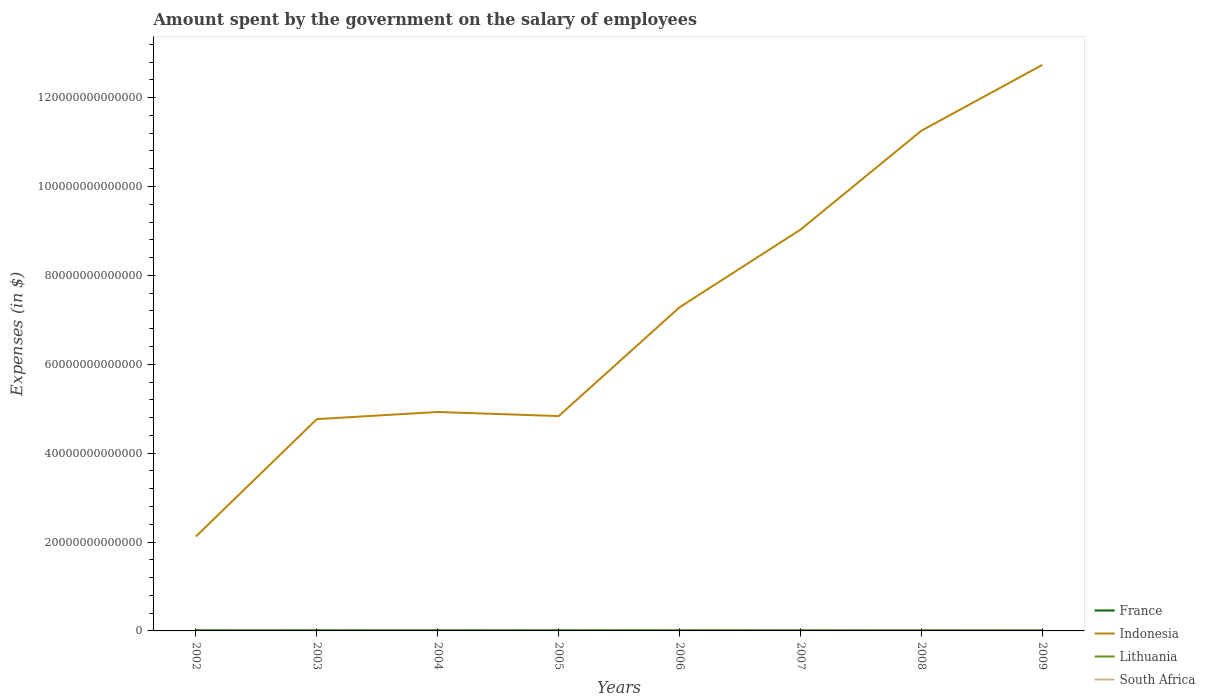How many different coloured lines are there?
Keep it short and to the point. 4. Does the line corresponding to Lithuania intersect with the line corresponding to South Africa?
Your response must be concise. No. Across all years, what is the maximum amount spent on the salary of employees by the government in Lithuania?
Provide a short and direct response. 2.72e+09. In which year was the amount spent on the salary of employees by the government in Indonesia maximum?
Offer a very short reply. 2002. What is the total amount spent on the salary of employees by the government in Lithuania in the graph?
Provide a short and direct response. -7.26e+08. What is the difference between the highest and the second highest amount spent on the salary of employees by the government in South Africa?
Provide a succinct answer. 6.03e+1. What is the difference between the highest and the lowest amount spent on the salary of employees by the government in South Africa?
Ensure brevity in your answer.  3. How many lines are there?
Give a very brief answer. 4. How many years are there in the graph?
Offer a very short reply. 8. What is the difference between two consecutive major ticks on the Y-axis?
Provide a short and direct response. 2.00e+13. Are the values on the major ticks of Y-axis written in scientific E-notation?
Provide a short and direct response. No. Does the graph contain any zero values?
Provide a succinct answer. No. How many legend labels are there?
Provide a succinct answer. 4. How are the legend labels stacked?
Ensure brevity in your answer.  Vertical. What is the title of the graph?
Provide a succinct answer. Amount spent by the government on the salary of employees. Does "Trinidad and Tobago" appear as one of the legend labels in the graph?
Ensure brevity in your answer.  No. What is the label or title of the Y-axis?
Make the answer very short. Expenses (in $). What is the Expenses (in $) in France in 2002?
Provide a succinct answer. 1.61e+11. What is the Expenses (in $) of Indonesia in 2002?
Keep it short and to the point. 2.13e+13. What is the Expenses (in $) in Lithuania in 2002?
Your answer should be very brief. 2.72e+09. What is the Expenses (in $) in South Africa in 2002?
Ensure brevity in your answer.  4.84e+1. What is the Expenses (in $) in France in 2003?
Provide a succinct answer. 1.66e+11. What is the Expenses (in $) in Indonesia in 2003?
Offer a very short reply. 4.77e+13. What is the Expenses (in $) in Lithuania in 2003?
Your answer should be compact. 2.88e+09. What is the Expenses (in $) in South Africa in 2003?
Keep it short and to the point. 5.39e+1. What is the Expenses (in $) in France in 2004?
Give a very brief answer. 1.69e+11. What is the Expenses (in $) in Indonesia in 2004?
Your response must be concise. 4.93e+13. What is the Expenses (in $) of Lithuania in 2004?
Provide a short and direct response. 3.27e+09. What is the Expenses (in $) of South Africa in 2004?
Offer a very short reply. 6.02e+1. What is the Expenses (in $) in France in 2005?
Your answer should be very brief. 1.74e+11. What is the Expenses (in $) of Indonesia in 2005?
Ensure brevity in your answer.  4.84e+13. What is the Expenses (in $) in Lithuania in 2005?
Make the answer very short. 3.97e+09. What is the Expenses (in $) in South Africa in 2005?
Ensure brevity in your answer.  6.73e+1. What is the Expenses (in $) in France in 2006?
Make the answer very short. 1.78e+11. What is the Expenses (in $) in Indonesia in 2006?
Give a very brief answer. 7.28e+13. What is the Expenses (in $) in Lithuania in 2006?
Your answer should be very brief. 4.64e+09. What is the Expenses (in $) in South Africa in 2006?
Offer a very short reply. 7.34e+1. What is the Expenses (in $) in France in 2007?
Keep it short and to the point. 1.81e+11. What is the Expenses (in $) in Indonesia in 2007?
Your answer should be very brief. 9.03e+13. What is the Expenses (in $) of Lithuania in 2007?
Offer a very short reply. 5.09e+09. What is the Expenses (in $) of South Africa in 2007?
Your response must be concise. 8.43e+1. What is the Expenses (in $) of France in 2008?
Offer a very short reply. 1.83e+11. What is the Expenses (in $) of Indonesia in 2008?
Offer a very short reply. 1.13e+14. What is the Expenses (in $) of Lithuania in 2008?
Make the answer very short. 6.20e+09. What is the Expenses (in $) in South Africa in 2008?
Keep it short and to the point. 9.49e+1. What is the Expenses (in $) in France in 2009?
Provide a short and direct response. 1.87e+11. What is the Expenses (in $) of Indonesia in 2009?
Offer a very short reply. 1.27e+14. What is the Expenses (in $) of Lithuania in 2009?
Provide a short and direct response. 5.82e+09. What is the Expenses (in $) of South Africa in 2009?
Your response must be concise. 1.09e+11. Across all years, what is the maximum Expenses (in $) in France?
Ensure brevity in your answer.  1.87e+11. Across all years, what is the maximum Expenses (in $) of Indonesia?
Make the answer very short. 1.27e+14. Across all years, what is the maximum Expenses (in $) of Lithuania?
Your answer should be compact. 6.20e+09. Across all years, what is the maximum Expenses (in $) of South Africa?
Ensure brevity in your answer.  1.09e+11. Across all years, what is the minimum Expenses (in $) in France?
Make the answer very short. 1.61e+11. Across all years, what is the minimum Expenses (in $) in Indonesia?
Keep it short and to the point. 2.13e+13. Across all years, what is the minimum Expenses (in $) in Lithuania?
Provide a succinct answer. 2.72e+09. Across all years, what is the minimum Expenses (in $) in South Africa?
Your answer should be compact. 4.84e+1. What is the total Expenses (in $) of France in the graph?
Your answer should be compact. 1.40e+12. What is the total Expenses (in $) of Indonesia in the graph?
Make the answer very short. 5.70e+14. What is the total Expenses (in $) of Lithuania in the graph?
Provide a succinct answer. 3.46e+1. What is the total Expenses (in $) of South Africa in the graph?
Make the answer very short. 5.91e+11. What is the difference between the Expenses (in $) of France in 2002 and that in 2003?
Your response must be concise. -4.66e+09. What is the difference between the Expenses (in $) of Indonesia in 2002 and that in 2003?
Make the answer very short. -2.64e+13. What is the difference between the Expenses (in $) in Lithuania in 2002 and that in 2003?
Your answer should be compact. -1.67e+08. What is the difference between the Expenses (in $) of South Africa in 2002 and that in 2003?
Provide a succinct answer. -5.52e+09. What is the difference between the Expenses (in $) of France in 2002 and that in 2004?
Provide a short and direct response. -8.00e+09. What is the difference between the Expenses (in $) in Indonesia in 2002 and that in 2004?
Provide a succinct answer. -2.80e+13. What is the difference between the Expenses (in $) of Lithuania in 2002 and that in 2004?
Offer a terse response. -5.48e+08. What is the difference between the Expenses (in $) in South Africa in 2002 and that in 2004?
Offer a terse response. -1.18e+1. What is the difference between the Expenses (in $) in France in 2002 and that in 2005?
Your response must be concise. -1.31e+1. What is the difference between the Expenses (in $) in Indonesia in 2002 and that in 2005?
Provide a succinct answer. -2.71e+13. What is the difference between the Expenses (in $) in Lithuania in 2002 and that in 2005?
Make the answer very short. -1.26e+09. What is the difference between the Expenses (in $) in South Africa in 2002 and that in 2005?
Offer a very short reply. -1.89e+1. What is the difference between the Expenses (in $) of France in 2002 and that in 2006?
Ensure brevity in your answer.  -1.65e+1. What is the difference between the Expenses (in $) of Indonesia in 2002 and that in 2006?
Ensure brevity in your answer.  -5.16e+13. What is the difference between the Expenses (in $) of Lithuania in 2002 and that in 2006?
Give a very brief answer. -1.92e+09. What is the difference between the Expenses (in $) of South Africa in 2002 and that in 2006?
Ensure brevity in your answer.  -2.50e+1. What is the difference between the Expenses (in $) of France in 2002 and that in 2007?
Offer a very short reply. -2.00e+1. What is the difference between the Expenses (in $) in Indonesia in 2002 and that in 2007?
Give a very brief answer. -6.90e+13. What is the difference between the Expenses (in $) of Lithuania in 2002 and that in 2007?
Offer a very short reply. -2.38e+09. What is the difference between the Expenses (in $) in South Africa in 2002 and that in 2007?
Your answer should be very brief. -3.59e+1. What is the difference between the Expenses (in $) in France in 2002 and that in 2008?
Your answer should be compact. -2.20e+1. What is the difference between the Expenses (in $) of Indonesia in 2002 and that in 2008?
Provide a succinct answer. -9.13e+13. What is the difference between the Expenses (in $) of Lithuania in 2002 and that in 2008?
Your response must be concise. -3.48e+09. What is the difference between the Expenses (in $) of South Africa in 2002 and that in 2008?
Your answer should be very brief. -4.65e+1. What is the difference between the Expenses (in $) in France in 2002 and that in 2009?
Keep it short and to the point. -2.65e+1. What is the difference between the Expenses (in $) in Indonesia in 2002 and that in 2009?
Your answer should be compact. -1.06e+14. What is the difference between the Expenses (in $) in Lithuania in 2002 and that in 2009?
Provide a succinct answer. -3.10e+09. What is the difference between the Expenses (in $) of South Africa in 2002 and that in 2009?
Your answer should be compact. -6.03e+1. What is the difference between the Expenses (in $) of France in 2003 and that in 2004?
Keep it short and to the point. -3.34e+09. What is the difference between the Expenses (in $) of Indonesia in 2003 and that in 2004?
Provide a succinct answer. -1.61e+12. What is the difference between the Expenses (in $) in Lithuania in 2003 and that in 2004?
Your response must be concise. -3.80e+08. What is the difference between the Expenses (in $) in South Africa in 2003 and that in 2004?
Offer a very short reply. -6.29e+09. What is the difference between the Expenses (in $) in France in 2003 and that in 2005?
Provide a short and direct response. -8.40e+09. What is the difference between the Expenses (in $) of Indonesia in 2003 and that in 2005?
Provide a short and direct response. -6.89e+11. What is the difference between the Expenses (in $) of Lithuania in 2003 and that in 2005?
Your response must be concise. -1.09e+09. What is the difference between the Expenses (in $) of South Africa in 2003 and that in 2005?
Give a very brief answer. -1.34e+1. What is the difference between the Expenses (in $) in France in 2003 and that in 2006?
Make the answer very short. -1.19e+1. What is the difference between the Expenses (in $) of Indonesia in 2003 and that in 2006?
Your answer should be very brief. -2.52e+13. What is the difference between the Expenses (in $) of Lithuania in 2003 and that in 2006?
Your answer should be very brief. -1.75e+09. What is the difference between the Expenses (in $) of South Africa in 2003 and that in 2006?
Make the answer very short. -1.95e+1. What is the difference between the Expenses (in $) of France in 2003 and that in 2007?
Your answer should be very brief. -1.53e+1. What is the difference between the Expenses (in $) in Indonesia in 2003 and that in 2007?
Offer a very short reply. -4.26e+13. What is the difference between the Expenses (in $) in Lithuania in 2003 and that in 2007?
Provide a succinct answer. -2.21e+09. What is the difference between the Expenses (in $) in South Africa in 2003 and that in 2007?
Keep it short and to the point. -3.04e+1. What is the difference between the Expenses (in $) in France in 2003 and that in 2008?
Provide a short and direct response. -1.73e+1. What is the difference between the Expenses (in $) of Indonesia in 2003 and that in 2008?
Your answer should be very brief. -6.49e+13. What is the difference between the Expenses (in $) of Lithuania in 2003 and that in 2008?
Provide a succinct answer. -3.31e+09. What is the difference between the Expenses (in $) in South Africa in 2003 and that in 2008?
Provide a succinct answer. -4.10e+1. What is the difference between the Expenses (in $) of France in 2003 and that in 2009?
Your answer should be very brief. -2.18e+1. What is the difference between the Expenses (in $) of Indonesia in 2003 and that in 2009?
Provide a short and direct response. -7.97e+13. What is the difference between the Expenses (in $) of Lithuania in 2003 and that in 2009?
Provide a succinct answer. -2.93e+09. What is the difference between the Expenses (in $) of South Africa in 2003 and that in 2009?
Give a very brief answer. -5.48e+1. What is the difference between the Expenses (in $) in France in 2004 and that in 2005?
Your response must be concise. -5.05e+09. What is the difference between the Expenses (in $) in Indonesia in 2004 and that in 2005?
Provide a short and direct response. 9.19e+11. What is the difference between the Expenses (in $) in Lithuania in 2004 and that in 2005?
Provide a succinct answer. -7.08e+08. What is the difference between the Expenses (in $) in South Africa in 2004 and that in 2005?
Your answer should be very brief. -7.08e+09. What is the difference between the Expenses (in $) in France in 2004 and that in 2006?
Your answer should be very brief. -8.55e+09. What is the difference between the Expenses (in $) in Indonesia in 2004 and that in 2006?
Provide a succinct answer. -2.36e+13. What is the difference between the Expenses (in $) in Lithuania in 2004 and that in 2006?
Provide a short and direct response. -1.37e+09. What is the difference between the Expenses (in $) of South Africa in 2004 and that in 2006?
Give a very brief answer. -1.32e+1. What is the difference between the Expenses (in $) of France in 2004 and that in 2007?
Your answer should be compact. -1.20e+1. What is the difference between the Expenses (in $) of Indonesia in 2004 and that in 2007?
Provide a succinct answer. -4.10e+13. What is the difference between the Expenses (in $) in Lithuania in 2004 and that in 2007?
Your answer should be compact. -1.83e+09. What is the difference between the Expenses (in $) of South Africa in 2004 and that in 2007?
Provide a succinct answer. -2.41e+1. What is the difference between the Expenses (in $) of France in 2004 and that in 2008?
Offer a very short reply. -1.40e+1. What is the difference between the Expenses (in $) in Indonesia in 2004 and that in 2008?
Make the answer very short. -6.33e+13. What is the difference between the Expenses (in $) of Lithuania in 2004 and that in 2008?
Offer a very short reply. -2.93e+09. What is the difference between the Expenses (in $) in South Africa in 2004 and that in 2008?
Provide a short and direct response. -3.47e+1. What is the difference between the Expenses (in $) of France in 2004 and that in 2009?
Ensure brevity in your answer.  -1.85e+1. What is the difference between the Expenses (in $) in Indonesia in 2004 and that in 2009?
Offer a very short reply. -7.81e+13. What is the difference between the Expenses (in $) in Lithuania in 2004 and that in 2009?
Offer a very short reply. -2.55e+09. What is the difference between the Expenses (in $) of South Africa in 2004 and that in 2009?
Your response must be concise. -4.85e+1. What is the difference between the Expenses (in $) in France in 2005 and that in 2006?
Offer a terse response. -3.49e+09. What is the difference between the Expenses (in $) of Indonesia in 2005 and that in 2006?
Offer a very short reply. -2.45e+13. What is the difference between the Expenses (in $) in Lithuania in 2005 and that in 2006?
Offer a terse response. -6.63e+08. What is the difference between the Expenses (in $) in South Africa in 2005 and that in 2006?
Make the answer very short. -6.12e+09. What is the difference between the Expenses (in $) in France in 2005 and that in 2007?
Provide a succinct answer. -6.93e+09. What is the difference between the Expenses (in $) of Indonesia in 2005 and that in 2007?
Keep it short and to the point. -4.20e+13. What is the difference between the Expenses (in $) in Lithuania in 2005 and that in 2007?
Provide a succinct answer. -1.12e+09. What is the difference between the Expenses (in $) of South Africa in 2005 and that in 2007?
Offer a terse response. -1.70e+1. What is the difference between the Expenses (in $) in France in 2005 and that in 2008?
Your answer should be very brief. -8.95e+09. What is the difference between the Expenses (in $) in Indonesia in 2005 and that in 2008?
Give a very brief answer. -6.42e+13. What is the difference between the Expenses (in $) in Lithuania in 2005 and that in 2008?
Provide a succinct answer. -2.23e+09. What is the difference between the Expenses (in $) in South Africa in 2005 and that in 2008?
Offer a terse response. -2.77e+1. What is the difference between the Expenses (in $) in France in 2005 and that in 2009?
Ensure brevity in your answer.  -1.34e+1. What is the difference between the Expenses (in $) of Indonesia in 2005 and that in 2009?
Offer a very short reply. -7.90e+13. What is the difference between the Expenses (in $) of Lithuania in 2005 and that in 2009?
Ensure brevity in your answer.  -1.85e+09. What is the difference between the Expenses (in $) in South Africa in 2005 and that in 2009?
Ensure brevity in your answer.  -4.14e+1. What is the difference between the Expenses (in $) in France in 2006 and that in 2007?
Offer a terse response. -3.43e+09. What is the difference between the Expenses (in $) of Indonesia in 2006 and that in 2007?
Offer a very short reply. -1.75e+13. What is the difference between the Expenses (in $) of Lithuania in 2006 and that in 2007?
Provide a short and direct response. -4.57e+08. What is the difference between the Expenses (in $) of South Africa in 2006 and that in 2007?
Your answer should be very brief. -1.09e+1. What is the difference between the Expenses (in $) of France in 2006 and that in 2008?
Your answer should be very brief. -5.45e+09. What is the difference between the Expenses (in $) in Indonesia in 2006 and that in 2008?
Keep it short and to the point. -3.97e+13. What is the difference between the Expenses (in $) of Lithuania in 2006 and that in 2008?
Give a very brief answer. -1.56e+09. What is the difference between the Expenses (in $) in South Africa in 2006 and that in 2008?
Give a very brief answer. -2.15e+1. What is the difference between the Expenses (in $) of France in 2006 and that in 2009?
Provide a short and direct response. -9.93e+09. What is the difference between the Expenses (in $) of Indonesia in 2006 and that in 2009?
Your answer should be very brief. -5.45e+13. What is the difference between the Expenses (in $) of Lithuania in 2006 and that in 2009?
Ensure brevity in your answer.  -1.18e+09. What is the difference between the Expenses (in $) of South Africa in 2006 and that in 2009?
Offer a terse response. -3.53e+1. What is the difference between the Expenses (in $) in France in 2007 and that in 2008?
Your answer should be very brief. -2.02e+09. What is the difference between the Expenses (in $) of Indonesia in 2007 and that in 2008?
Offer a very short reply. -2.23e+13. What is the difference between the Expenses (in $) of Lithuania in 2007 and that in 2008?
Offer a terse response. -1.11e+09. What is the difference between the Expenses (in $) in South Africa in 2007 and that in 2008?
Give a very brief answer. -1.06e+1. What is the difference between the Expenses (in $) in France in 2007 and that in 2009?
Provide a short and direct response. -6.49e+09. What is the difference between the Expenses (in $) of Indonesia in 2007 and that in 2009?
Make the answer very short. -3.71e+13. What is the difference between the Expenses (in $) of Lithuania in 2007 and that in 2009?
Provide a succinct answer. -7.26e+08. What is the difference between the Expenses (in $) in South Africa in 2007 and that in 2009?
Offer a very short reply. -2.44e+1. What is the difference between the Expenses (in $) of France in 2008 and that in 2009?
Give a very brief answer. -4.48e+09. What is the difference between the Expenses (in $) of Indonesia in 2008 and that in 2009?
Give a very brief answer. -1.48e+13. What is the difference between the Expenses (in $) in Lithuania in 2008 and that in 2009?
Provide a succinct answer. 3.80e+08. What is the difference between the Expenses (in $) of South Africa in 2008 and that in 2009?
Offer a terse response. -1.38e+1. What is the difference between the Expenses (in $) of France in 2002 and the Expenses (in $) of Indonesia in 2003?
Keep it short and to the point. -4.75e+13. What is the difference between the Expenses (in $) of France in 2002 and the Expenses (in $) of Lithuania in 2003?
Offer a very short reply. 1.58e+11. What is the difference between the Expenses (in $) of France in 2002 and the Expenses (in $) of South Africa in 2003?
Make the answer very short. 1.07e+11. What is the difference between the Expenses (in $) of Indonesia in 2002 and the Expenses (in $) of Lithuania in 2003?
Offer a terse response. 2.13e+13. What is the difference between the Expenses (in $) in Indonesia in 2002 and the Expenses (in $) in South Africa in 2003?
Offer a very short reply. 2.12e+13. What is the difference between the Expenses (in $) of Lithuania in 2002 and the Expenses (in $) of South Africa in 2003?
Keep it short and to the point. -5.12e+1. What is the difference between the Expenses (in $) in France in 2002 and the Expenses (in $) in Indonesia in 2004?
Keep it short and to the point. -4.91e+13. What is the difference between the Expenses (in $) in France in 2002 and the Expenses (in $) in Lithuania in 2004?
Your response must be concise. 1.58e+11. What is the difference between the Expenses (in $) in France in 2002 and the Expenses (in $) in South Africa in 2004?
Offer a very short reply. 1.01e+11. What is the difference between the Expenses (in $) in Indonesia in 2002 and the Expenses (in $) in Lithuania in 2004?
Give a very brief answer. 2.13e+13. What is the difference between the Expenses (in $) in Indonesia in 2002 and the Expenses (in $) in South Africa in 2004?
Your answer should be compact. 2.12e+13. What is the difference between the Expenses (in $) in Lithuania in 2002 and the Expenses (in $) in South Africa in 2004?
Offer a terse response. -5.75e+1. What is the difference between the Expenses (in $) in France in 2002 and the Expenses (in $) in Indonesia in 2005?
Offer a very short reply. -4.82e+13. What is the difference between the Expenses (in $) of France in 2002 and the Expenses (in $) of Lithuania in 2005?
Ensure brevity in your answer.  1.57e+11. What is the difference between the Expenses (in $) in France in 2002 and the Expenses (in $) in South Africa in 2005?
Provide a short and direct response. 9.37e+1. What is the difference between the Expenses (in $) of Indonesia in 2002 and the Expenses (in $) of Lithuania in 2005?
Provide a short and direct response. 2.13e+13. What is the difference between the Expenses (in $) in Indonesia in 2002 and the Expenses (in $) in South Africa in 2005?
Offer a terse response. 2.12e+13. What is the difference between the Expenses (in $) of Lithuania in 2002 and the Expenses (in $) of South Africa in 2005?
Give a very brief answer. -6.46e+1. What is the difference between the Expenses (in $) of France in 2002 and the Expenses (in $) of Indonesia in 2006?
Make the answer very short. -7.27e+13. What is the difference between the Expenses (in $) in France in 2002 and the Expenses (in $) in Lithuania in 2006?
Your response must be concise. 1.56e+11. What is the difference between the Expenses (in $) in France in 2002 and the Expenses (in $) in South Africa in 2006?
Ensure brevity in your answer.  8.76e+1. What is the difference between the Expenses (in $) in Indonesia in 2002 and the Expenses (in $) in Lithuania in 2006?
Offer a terse response. 2.13e+13. What is the difference between the Expenses (in $) of Indonesia in 2002 and the Expenses (in $) of South Africa in 2006?
Ensure brevity in your answer.  2.12e+13. What is the difference between the Expenses (in $) in Lithuania in 2002 and the Expenses (in $) in South Africa in 2006?
Provide a succinct answer. -7.07e+1. What is the difference between the Expenses (in $) of France in 2002 and the Expenses (in $) of Indonesia in 2007?
Your answer should be compact. -9.01e+13. What is the difference between the Expenses (in $) in France in 2002 and the Expenses (in $) in Lithuania in 2007?
Offer a very short reply. 1.56e+11. What is the difference between the Expenses (in $) in France in 2002 and the Expenses (in $) in South Africa in 2007?
Ensure brevity in your answer.  7.67e+1. What is the difference between the Expenses (in $) of Indonesia in 2002 and the Expenses (in $) of Lithuania in 2007?
Provide a short and direct response. 2.13e+13. What is the difference between the Expenses (in $) of Indonesia in 2002 and the Expenses (in $) of South Africa in 2007?
Offer a terse response. 2.12e+13. What is the difference between the Expenses (in $) in Lithuania in 2002 and the Expenses (in $) in South Africa in 2007?
Make the answer very short. -8.16e+1. What is the difference between the Expenses (in $) in France in 2002 and the Expenses (in $) in Indonesia in 2008?
Offer a very short reply. -1.12e+14. What is the difference between the Expenses (in $) in France in 2002 and the Expenses (in $) in Lithuania in 2008?
Make the answer very short. 1.55e+11. What is the difference between the Expenses (in $) of France in 2002 and the Expenses (in $) of South Africa in 2008?
Ensure brevity in your answer.  6.61e+1. What is the difference between the Expenses (in $) in Indonesia in 2002 and the Expenses (in $) in Lithuania in 2008?
Offer a very short reply. 2.13e+13. What is the difference between the Expenses (in $) of Indonesia in 2002 and the Expenses (in $) of South Africa in 2008?
Your answer should be very brief. 2.12e+13. What is the difference between the Expenses (in $) of Lithuania in 2002 and the Expenses (in $) of South Africa in 2008?
Your response must be concise. -9.22e+1. What is the difference between the Expenses (in $) in France in 2002 and the Expenses (in $) in Indonesia in 2009?
Provide a short and direct response. -1.27e+14. What is the difference between the Expenses (in $) of France in 2002 and the Expenses (in $) of Lithuania in 2009?
Your answer should be very brief. 1.55e+11. What is the difference between the Expenses (in $) in France in 2002 and the Expenses (in $) in South Africa in 2009?
Offer a very short reply. 5.23e+1. What is the difference between the Expenses (in $) of Indonesia in 2002 and the Expenses (in $) of Lithuania in 2009?
Make the answer very short. 2.13e+13. What is the difference between the Expenses (in $) of Indonesia in 2002 and the Expenses (in $) of South Africa in 2009?
Your response must be concise. 2.12e+13. What is the difference between the Expenses (in $) of Lithuania in 2002 and the Expenses (in $) of South Africa in 2009?
Your answer should be very brief. -1.06e+11. What is the difference between the Expenses (in $) of France in 2003 and the Expenses (in $) of Indonesia in 2004?
Provide a short and direct response. -4.91e+13. What is the difference between the Expenses (in $) of France in 2003 and the Expenses (in $) of Lithuania in 2004?
Your answer should be compact. 1.62e+11. What is the difference between the Expenses (in $) in France in 2003 and the Expenses (in $) in South Africa in 2004?
Offer a terse response. 1.05e+11. What is the difference between the Expenses (in $) in Indonesia in 2003 and the Expenses (in $) in Lithuania in 2004?
Provide a short and direct response. 4.77e+13. What is the difference between the Expenses (in $) of Indonesia in 2003 and the Expenses (in $) of South Africa in 2004?
Make the answer very short. 4.76e+13. What is the difference between the Expenses (in $) of Lithuania in 2003 and the Expenses (in $) of South Africa in 2004?
Your response must be concise. -5.73e+1. What is the difference between the Expenses (in $) in France in 2003 and the Expenses (in $) in Indonesia in 2005?
Make the answer very short. -4.82e+13. What is the difference between the Expenses (in $) in France in 2003 and the Expenses (in $) in Lithuania in 2005?
Your response must be concise. 1.62e+11. What is the difference between the Expenses (in $) in France in 2003 and the Expenses (in $) in South Africa in 2005?
Your response must be concise. 9.84e+1. What is the difference between the Expenses (in $) in Indonesia in 2003 and the Expenses (in $) in Lithuania in 2005?
Ensure brevity in your answer.  4.77e+13. What is the difference between the Expenses (in $) in Indonesia in 2003 and the Expenses (in $) in South Africa in 2005?
Provide a short and direct response. 4.76e+13. What is the difference between the Expenses (in $) of Lithuania in 2003 and the Expenses (in $) of South Africa in 2005?
Offer a very short reply. -6.44e+1. What is the difference between the Expenses (in $) in France in 2003 and the Expenses (in $) in Indonesia in 2006?
Your response must be concise. -7.27e+13. What is the difference between the Expenses (in $) in France in 2003 and the Expenses (in $) in Lithuania in 2006?
Your answer should be compact. 1.61e+11. What is the difference between the Expenses (in $) of France in 2003 and the Expenses (in $) of South Africa in 2006?
Ensure brevity in your answer.  9.22e+1. What is the difference between the Expenses (in $) in Indonesia in 2003 and the Expenses (in $) in Lithuania in 2006?
Provide a succinct answer. 4.77e+13. What is the difference between the Expenses (in $) in Indonesia in 2003 and the Expenses (in $) in South Africa in 2006?
Offer a terse response. 4.76e+13. What is the difference between the Expenses (in $) of Lithuania in 2003 and the Expenses (in $) of South Africa in 2006?
Your answer should be compact. -7.05e+1. What is the difference between the Expenses (in $) of France in 2003 and the Expenses (in $) of Indonesia in 2007?
Provide a short and direct response. -9.01e+13. What is the difference between the Expenses (in $) of France in 2003 and the Expenses (in $) of Lithuania in 2007?
Provide a short and direct response. 1.61e+11. What is the difference between the Expenses (in $) of France in 2003 and the Expenses (in $) of South Africa in 2007?
Offer a terse response. 8.14e+1. What is the difference between the Expenses (in $) of Indonesia in 2003 and the Expenses (in $) of Lithuania in 2007?
Ensure brevity in your answer.  4.77e+13. What is the difference between the Expenses (in $) in Indonesia in 2003 and the Expenses (in $) in South Africa in 2007?
Provide a short and direct response. 4.76e+13. What is the difference between the Expenses (in $) in Lithuania in 2003 and the Expenses (in $) in South Africa in 2007?
Provide a short and direct response. -8.14e+1. What is the difference between the Expenses (in $) of France in 2003 and the Expenses (in $) of Indonesia in 2008?
Offer a terse response. -1.12e+14. What is the difference between the Expenses (in $) in France in 2003 and the Expenses (in $) in Lithuania in 2008?
Your response must be concise. 1.59e+11. What is the difference between the Expenses (in $) in France in 2003 and the Expenses (in $) in South Africa in 2008?
Ensure brevity in your answer.  7.07e+1. What is the difference between the Expenses (in $) in Indonesia in 2003 and the Expenses (in $) in Lithuania in 2008?
Provide a short and direct response. 4.77e+13. What is the difference between the Expenses (in $) of Indonesia in 2003 and the Expenses (in $) of South Africa in 2008?
Your answer should be compact. 4.76e+13. What is the difference between the Expenses (in $) of Lithuania in 2003 and the Expenses (in $) of South Africa in 2008?
Offer a very short reply. -9.21e+1. What is the difference between the Expenses (in $) in France in 2003 and the Expenses (in $) in Indonesia in 2009?
Offer a terse response. -1.27e+14. What is the difference between the Expenses (in $) in France in 2003 and the Expenses (in $) in Lithuania in 2009?
Your answer should be very brief. 1.60e+11. What is the difference between the Expenses (in $) in France in 2003 and the Expenses (in $) in South Africa in 2009?
Your response must be concise. 5.70e+1. What is the difference between the Expenses (in $) of Indonesia in 2003 and the Expenses (in $) of Lithuania in 2009?
Your answer should be compact. 4.77e+13. What is the difference between the Expenses (in $) of Indonesia in 2003 and the Expenses (in $) of South Africa in 2009?
Make the answer very short. 4.76e+13. What is the difference between the Expenses (in $) of Lithuania in 2003 and the Expenses (in $) of South Africa in 2009?
Provide a succinct answer. -1.06e+11. What is the difference between the Expenses (in $) of France in 2004 and the Expenses (in $) of Indonesia in 2005?
Your answer should be compact. -4.82e+13. What is the difference between the Expenses (in $) in France in 2004 and the Expenses (in $) in Lithuania in 2005?
Ensure brevity in your answer.  1.65e+11. What is the difference between the Expenses (in $) in France in 2004 and the Expenses (in $) in South Africa in 2005?
Ensure brevity in your answer.  1.02e+11. What is the difference between the Expenses (in $) of Indonesia in 2004 and the Expenses (in $) of Lithuania in 2005?
Make the answer very short. 4.93e+13. What is the difference between the Expenses (in $) of Indonesia in 2004 and the Expenses (in $) of South Africa in 2005?
Give a very brief answer. 4.92e+13. What is the difference between the Expenses (in $) in Lithuania in 2004 and the Expenses (in $) in South Africa in 2005?
Offer a very short reply. -6.40e+1. What is the difference between the Expenses (in $) in France in 2004 and the Expenses (in $) in Indonesia in 2006?
Keep it short and to the point. -7.27e+13. What is the difference between the Expenses (in $) in France in 2004 and the Expenses (in $) in Lithuania in 2006?
Keep it short and to the point. 1.64e+11. What is the difference between the Expenses (in $) in France in 2004 and the Expenses (in $) in South Africa in 2006?
Make the answer very short. 9.56e+1. What is the difference between the Expenses (in $) in Indonesia in 2004 and the Expenses (in $) in Lithuania in 2006?
Offer a very short reply. 4.93e+13. What is the difference between the Expenses (in $) in Indonesia in 2004 and the Expenses (in $) in South Africa in 2006?
Make the answer very short. 4.92e+13. What is the difference between the Expenses (in $) in Lithuania in 2004 and the Expenses (in $) in South Africa in 2006?
Keep it short and to the point. -7.01e+1. What is the difference between the Expenses (in $) in France in 2004 and the Expenses (in $) in Indonesia in 2007?
Provide a succinct answer. -9.01e+13. What is the difference between the Expenses (in $) in France in 2004 and the Expenses (in $) in Lithuania in 2007?
Your answer should be very brief. 1.64e+11. What is the difference between the Expenses (in $) of France in 2004 and the Expenses (in $) of South Africa in 2007?
Give a very brief answer. 8.47e+1. What is the difference between the Expenses (in $) in Indonesia in 2004 and the Expenses (in $) in Lithuania in 2007?
Your response must be concise. 4.93e+13. What is the difference between the Expenses (in $) in Indonesia in 2004 and the Expenses (in $) in South Africa in 2007?
Offer a very short reply. 4.92e+13. What is the difference between the Expenses (in $) in Lithuania in 2004 and the Expenses (in $) in South Africa in 2007?
Make the answer very short. -8.10e+1. What is the difference between the Expenses (in $) of France in 2004 and the Expenses (in $) of Indonesia in 2008?
Give a very brief answer. -1.12e+14. What is the difference between the Expenses (in $) of France in 2004 and the Expenses (in $) of Lithuania in 2008?
Provide a short and direct response. 1.63e+11. What is the difference between the Expenses (in $) of France in 2004 and the Expenses (in $) of South Africa in 2008?
Your response must be concise. 7.41e+1. What is the difference between the Expenses (in $) in Indonesia in 2004 and the Expenses (in $) in Lithuania in 2008?
Offer a terse response. 4.93e+13. What is the difference between the Expenses (in $) of Indonesia in 2004 and the Expenses (in $) of South Africa in 2008?
Your answer should be very brief. 4.92e+13. What is the difference between the Expenses (in $) in Lithuania in 2004 and the Expenses (in $) in South Africa in 2008?
Keep it short and to the point. -9.17e+1. What is the difference between the Expenses (in $) in France in 2004 and the Expenses (in $) in Indonesia in 2009?
Offer a very short reply. -1.27e+14. What is the difference between the Expenses (in $) in France in 2004 and the Expenses (in $) in Lithuania in 2009?
Give a very brief answer. 1.63e+11. What is the difference between the Expenses (in $) in France in 2004 and the Expenses (in $) in South Africa in 2009?
Keep it short and to the point. 6.03e+1. What is the difference between the Expenses (in $) in Indonesia in 2004 and the Expenses (in $) in Lithuania in 2009?
Your response must be concise. 4.93e+13. What is the difference between the Expenses (in $) in Indonesia in 2004 and the Expenses (in $) in South Africa in 2009?
Give a very brief answer. 4.92e+13. What is the difference between the Expenses (in $) in Lithuania in 2004 and the Expenses (in $) in South Africa in 2009?
Give a very brief answer. -1.05e+11. What is the difference between the Expenses (in $) in France in 2005 and the Expenses (in $) in Indonesia in 2006?
Offer a terse response. -7.27e+13. What is the difference between the Expenses (in $) of France in 2005 and the Expenses (in $) of Lithuania in 2006?
Give a very brief answer. 1.69e+11. What is the difference between the Expenses (in $) in France in 2005 and the Expenses (in $) in South Africa in 2006?
Make the answer very short. 1.01e+11. What is the difference between the Expenses (in $) of Indonesia in 2005 and the Expenses (in $) of Lithuania in 2006?
Offer a very short reply. 4.83e+13. What is the difference between the Expenses (in $) of Indonesia in 2005 and the Expenses (in $) of South Africa in 2006?
Offer a very short reply. 4.83e+13. What is the difference between the Expenses (in $) of Lithuania in 2005 and the Expenses (in $) of South Africa in 2006?
Give a very brief answer. -6.94e+1. What is the difference between the Expenses (in $) of France in 2005 and the Expenses (in $) of Indonesia in 2007?
Your answer should be very brief. -9.01e+13. What is the difference between the Expenses (in $) in France in 2005 and the Expenses (in $) in Lithuania in 2007?
Keep it short and to the point. 1.69e+11. What is the difference between the Expenses (in $) of France in 2005 and the Expenses (in $) of South Africa in 2007?
Offer a terse response. 8.98e+1. What is the difference between the Expenses (in $) of Indonesia in 2005 and the Expenses (in $) of Lithuania in 2007?
Your answer should be compact. 4.83e+13. What is the difference between the Expenses (in $) of Indonesia in 2005 and the Expenses (in $) of South Africa in 2007?
Provide a short and direct response. 4.83e+13. What is the difference between the Expenses (in $) of Lithuania in 2005 and the Expenses (in $) of South Africa in 2007?
Make the answer very short. -8.03e+1. What is the difference between the Expenses (in $) of France in 2005 and the Expenses (in $) of Indonesia in 2008?
Offer a terse response. -1.12e+14. What is the difference between the Expenses (in $) of France in 2005 and the Expenses (in $) of Lithuania in 2008?
Offer a terse response. 1.68e+11. What is the difference between the Expenses (in $) in France in 2005 and the Expenses (in $) in South Africa in 2008?
Your answer should be very brief. 7.91e+1. What is the difference between the Expenses (in $) in Indonesia in 2005 and the Expenses (in $) in Lithuania in 2008?
Give a very brief answer. 4.83e+13. What is the difference between the Expenses (in $) of Indonesia in 2005 and the Expenses (in $) of South Africa in 2008?
Offer a terse response. 4.83e+13. What is the difference between the Expenses (in $) in Lithuania in 2005 and the Expenses (in $) in South Africa in 2008?
Give a very brief answer. -9.10e+1. What is the difference between the Expenses (in $) in France in 2005 and the Expenses (in $) in Indonesia in 2009?
Make the answer very short. -1.27e+14. What is the difference between the Expenses (in $) in France in 2005 and the Expenses (in $) in Lithuania in 2009?
Keep it short and to the point. 1.68e+11. What is the difference between the Expenses (in $) in France in 2005 and the Expenses (in $) in South Africa in 2009?
Ensure brevity in your answer.  6.53e+1. What is the difference between the Expenses (in $) of Indonesia in 2005 and the Expenses (in $) of Lithuania in 2009?
Give a very brief answer. 4.83e+13. What is the difference between the Expenses (in $) of Indonesia in 2005 and the Expenses (in $) of South Africa in 2009?
Your answer should be compact. 4.82e+13. What is the difference between the Expenses (in $) in Lithuania in 2005 and the Expenses (in $) in South Africa in 2009?
Provide a short and direct response. -1.05e+11. What is the difference between the Expenses (in $) in France in 2006 and the Expenses (in $) in Indonesia in 2007?
Ensure brevity in your answer.  -9.01e+13. What is the difference between the Expenses (in $) in France in 2006 and the Expenses (in $) in Lithuania in 2007?
Ensure brevity in your answer.  1.72e+11. What is the difference between the Expenses (in $) in France in 2006 and the Expenses (in $) in South Africa in 2007?
Keep it short and to the point. 9.32e+1. What is the difference between the Expenses (in $) in Indonesia in 2006 and the Expenses (in $) in Lithuania in 2007?
Offer a very short reply. 7.28e+13. What is the difference between the Expenses (in $) in Indonesia in 2006 and the Expenses (in $) in South Africa in 2007?
Give a very brief answer. 7.28e+13. What is the difference between the Expenses (in $) of Lithuania in 2006 and the Expenses (in $) of South Africa in 2007?
Make the answer very short. -7.97e+1. What is the difference between the Expenses (in $) of France in 2006 and the Expenses (in $) of Indonesia in 2008?
Keep it short and to the point. -1.12e+14. What is the difference between the Expenses (in $) of France in 2006 and the Expenses (in $) of Lithuania in 2008?
Give a very brief answer. 1.71e+11. What is the difference between the Expenses (in $) of France in 2006 and the Expenses (in $) of South Africa in 2008?
Give a very brief answer. 8.26e+1. What is the difference between the Expenses (in $) in Indonesia in 2006 and the Expenses (in $) in Lithuania in 2008?
Your answer should be compact. 7.28e+13. What is the difference between the Expenses (in $) in Indonesia in 2006 and the Expenses (in $) in South Africa in 2008?
Your answer should be compact. 7.27e+13. What is the difference between the Expenses (in $) of Lithuania in 2006 and the Expenses (in $) of South Africa in 2008?
Keep it short and to the point. -9.03e+1. What is the difference between the Expenses (in $) of France in 2006 and the Expenses (in $) of Indonesia in 2009?
Give a very brief answer. -1.27e+14. What is the difference between the Expenses (in $) in France in 2006 and the Expenses (in $) in Lithuania in 2009?
Offer a terse response. 1.72e+11. What is the difference between the Expenses (in $) of France in 2006 and the Expenses (in $) of South Africa in 2009?
Make the answer very short. 6.88e+1. What is the difference between the Expenses (in $) in Indonesia in 2006 and the Expenses (in $) in Lithuania in 2009?
Ensure brevity in your answer.  7.28e+13. What is the difference between the Expenses (in $) of Indonesia in 2006 and the Expenses (in $) of South Africa in 2009?
Your answer should be compact. 7.27e+13. What is the difference between the Expenses (in $) in Lithuania in 2006 and the Expenses (in $) in South Africa in 2009?
Ensure brevity in your answer.  -1.04e+11. What is the difference between the Expenses (in $) in France in 2007 and the Expenses (in $) in Indonesia in 2008?
Offer a terse response. -1.12e+14. What is the difference between the Expenses (in $) in France in 2007 and the Expenses (in $) in Lithuania in 2008?
Keep it short and to the point. 1.75e+11. What is the difference between the Expenses (in $) of France in 2007 and the Expenses (in $) of South Africa in 2008?
Offer a terse response. 8.60e+1. What is the difference between the Expenses (in $) of Indonesia in 2007 and the Expenses (in $) of Lithuania in 2008?
Your response must be concise. 9.03e+13. What is the difference between the Expenses (in $) in Indonesia in 2007 and the Expenses (in $) in South Africa in 2008?
Make the answer very short. 9.02e+13. What is the difference between the Expenses (in $) in Lithuania in 2007 and the Expenses (in $) in South Africa in 2008?
Your response must be concise. -8.98e+1. What is the difference between the Expenses (in $) in France in 2007 and the Expenses (in $) in Indonesia in 2009?
Keep it short and to the point. -1.27e+14. What is the difference between the Expenses (in $) of France in 2007 and the Expenses (in $) of Lithuania in 2009?
Give a very brief answer. 1.75e+11. What is the difference between the Expenses (in $) in France in 2007 and the Expenses (in $) in South Africa in 2009?
Provide a short and direct response. 7.23e+1. What is the difference between the Expenses (in $) of Indonesia in 2007 and the Expenses (in $) of Lithuania in 2009?
Keep it short and to the point. 9.03e+13. What is the difference between the Expenses (in $) in Indonesia in 2007 and the Expenses (in $) in South Africa in 2009?
Keep it short and to the point. 9.02e+13. What is the difference between the Expenses (in $) in Lithuania in 2007 and the Expenses (in $) in South Africa in 2009?
Offer a terse response. -1.04e+11. What is the difference between the Expenses (in $) of France in 2008 and the Expenses (in $) of Indonesia in 2009?
Give a very brief answer. -1.27e+14. What is the difference between the Expenses (in $) in France in 2008 and the Expenses (in $) in Lithuania in 2009?
Provide a short and direct response. 1.77e+11. What is the difference between the Expenses (in $) in France in 2008 and the Expenses (in $) in South Africa in 2009?
Keep it short and to the point. 7.43e+1. What is the difference between the Expenses (in $) in Indonesia in 2008 and the Expenses (in $) in Lithuania in 2009?
Ensure brevity in your answer.  1.13e+14. What is the difference between the Expenses (in $) in Indonesia in 2008 and the Expenses (in $) in South Africa in 2009?
Keep it short and to the point. 1.12e+14. What is the difference between the Expenses (in $) of Lithuania in 2008 and the Expenses (in $) of South Africa in 2009?
Keep it short and to the point. -1.02e+11. What is the average Expenses (in $) in France per year?
Offer a very short reply. 1.75e+11. What is the average Expenses (in $) of Indonesia per year?
Provide a short and direct response. 7.12e+13. What is the average Expenses (in $) in Lithuania per year?
Ensure brevity in your answer.  4.32e+09. What is the average Expenses (in $) of South Africa per year?
Offer a very short reply. 7.39e+1. In the year 2002, what is the difference between the Expenses (in $) of France and Expenses (in $) of Indonesia?
Offer a very short reply. -2.11e+13. In the year 2002, what is the difference between the Expenses (in $) in France and Expenses (in $) in Lithuania?
Provide a short and direct response. 1.58e+11. In the year 2002, what is the difference between the Expenses (in $) in France and Expenses (in $) in South Africa?
Offer a terse response. 1.13e+11. In the year 2002, what is the difference between the Expenses (in $) in Indonesia and Expenses (in $) in Lithuania?
Offer a very short reply. 2.13e+13. In the year 2002, what is the difference between the Expenses (in $) in Indonesia and Expenses (in $) in South Africa?
Give a very brief answer. 2.12e+13. In the year 2002, what is the difference between the Expenses (in $) of Lithuania and Expenses (in $) of South Africa?
Give a very brief answer. -4.57e+1. In the year 2003, what is the difference between the Expenses (in $) of France and Expenses (in $) of Indonesia?
Provide a succinct answer. -4.75e+13. In the year 2003, what is the difference between the Expenses (in $) in France and Expenses (in $) in Lithuania?
Your answer should be very brief. 1.63e+11. In the year 2003, what is the difference between the Expenses (in $) of France and Expenses (in $) of South Africa?
Offer a very short reply. 1.12e+11. In the year 2003, what is the difference between the Expenses (in $) of Indonesia and Expenses (in $) of Lithuania?
Give a very brief answer. 4.77e+13. In the year 2003, what is the difference between the Expenses (in $) of Indonesia and Expenses (in $) of South Africa?
Keep it short and to the point. 4.76e+13. In the year 2003, what is the difference between the Expenses (in $) in Lithuania and Expenses (in $) in South Africa?
Your response must be concise. -5.10e+1. In the year 2004, what is the difference between the Expenses (in $) of France and Expenses (in $) of Indonesia?
Give a very brief answer. -4.91e+13. In the year 2004, what is the difference between the Expenses (in $) in France and Expenses (in $) in Lithuania?
Make the answer very short. 1.66e+11. In the year 2004, what is the difference between the Expenses (in $) of France and Expenses (in $) of South Africa?
Provide a short and direct response. 1.09e+11. In the year 2004, what is the difference between the Expenses (in $) of Indonesia and Expenses (in $) of Lithuania?
Your answer should be compact. 4.93e+13. In the year 2004, what is the difference between the Expenses (in $) in Indonesia and Expenses (in $) in South Africa?
Your answer should be compact. 4.92e+13. In the year 2004, what is the difference between the Expenses (in $) of Lithuania and Expenses (in $) of South Africa?
Offer a very short reply. -5.69e+1. In the year 2005, what is the difference between the Expenses (in $) in France and Expenses (in $) in Indonesia?
Provide a short and direct response. -4.82e+13. In the year 2005, what is the difference between the Expenses (in $) of France and Expenses (in $) of Lithuania?
Ensure brevity in your answer.  1.70e+11. In the year 2005, what is the difference between the Expenses (in $) of France and Expenses (in $) of South Africa?
Your answer should be very brief. 1.07e+11. In the year 2005, what is the difference between the Expenses (in $) in Indonesia and Expenses (in $) in Lithuania?
Keep it short and to the point. 4.83e+13. In the year 2005, what is the difference between the Expenses (in $) of Indonesia and Expenses (in $) of South Africa?
Ensure brevity in your answer.  4.83e+13. In the year 2005, what is the difference between the Expenses (in $) of Lithuania and Expenses (in $) of South Africa?
Offer a terse response. -6.33e+1. In the year 2006, what is the difference between the Expenses (in $) of France and Expenses (in $) of Indonesia?
Your answer should be very brief. -7.27e+13. In the year 2006, what is the difference between the Expenses (in $) in France and Expenses (in $) in Lithuania?
Make the answer very short. 1.73e+11. In the year 2006, what is the difference between the Expenses (in $) in France and Expenses (in $) in South Africa?
Your response must be concise. 1.04e+11. In the year 2006, what is the difference between the Expenses (in $) in Indonesia and Expenses (in $) in Lithuania?
Provide a succinct answer. 7.28e+13. In the year 2006, what is the difference between the Expenses (in $) in Indonesia and Expenses (in $) in South Africa?
Provide a short and direct response. 7.28e+13. In the year 2006, what is the difference between the Expenses (in $) of Lithuania and Expenses (in $) of South Africa?
Provide a succinct answer. -6.88e+1. In the year 2007, what is the difference between the Expenses (in $) of France and Expenses (in $) of Indonesia?
Offer a very short reply. -9.01e+13. In the year 2007, what is the difference between the Expenses (in $) in France and Expenses (in $) in Lithuania?
Provide a succinct answer. 1.76e+11. In the year 2007, what is the difference between the Expenses (in $) of France and Expenses (in $) of South Africa?
Ensure brevity in your answer.  9.67e+1. In the year 2007, what is the difference between the Expenses (in $) in Indonesia and Expenses (in $) in Lithuania?
Provide a short and direct response. 9.03e+13. In the year 2007, what is the difference between the Expenses (in $) in Indonesia and Expenses (in $) in South Africa?
Ensure brevity in your answer.  9.02e+13. In the year 2007, what is the difference between the Expenses (in $) in Lithuania and Expenses (in $) in South Africa?
Your answer should be very brief. -7.92e+1. In the year 2008, what is the difference between the Expenses (in $) in France and Expenses (in $) in Indonesia?
Offer a terse response. -1.12e+14. In the year 2008, what is the difference between the Expenses (in $) in France and Expenses (in $) in Lithuania?
Make the answer very short. 1.77e+11. In the year 2008, what is the difference between the Expenses (in $) of France and Expenses (in $) of South Africa?
Ensure brevity in your answer.  8.81e+1. In the year 2008, what is the difference between the Expenses (in $) in Indonesia and Expenses (in $) in Lithuania?
Offer a terse response. 1.13e+14. In the year 2008, what is the difference between the Expenses (in $) of Indonesia and Expenses (in $) of South Africa?
Your answer should be compact. 1.12e+14. In the year 2008, what is the difference between the Expenses (in $) of Lithuania and Expenses (in $) of South Africa?
Provide a short and direct response. -8.87e+1. In the year 2009, what is the difference between the Expenses (in $) in France and Expenses (in $) in Indonesia?
Make the answer very short. -1.27e+14. In the year 2009, what is the difference between the Expenses (in $) of France and Expenses (in $) of Lithuania?
Your response must be concise. 1.82e+11. In the year 2009, what is the difference between the Expenses (in $) of France and Expenses (in $) of South Africa?
Your response must be concise. 7.88e+1. In the year 2009, what is the difference between the Expenses (in $) in Indonesia and Expenses (in $) in Lithuania?
Your answer should be very brief. 1.27e+14. In the year 2009, what is the difference between the Expenses (in $) in Indonesia and Expenses (in $) in South Africa?
Your answer should be very brief. 1.27e+14. In the year 2009, what is the difference between the Expenses (in $) in Lithuania and Expenses (in $) in South Africa?
Offer a very short reply. -1.03e+11. What is the ratio of the Expenses (in $) in France in 2002 to that in 2003?
Your answer should be very brief. 0.97. What is the ratio of the Expenses (in $) of Indonesia in 2002 to that in 2003?
Ensure brevity in your answer.  0.45. What is the ratio of the Expenses (in $) of Lithuania in 2002 to that in 2003?
Offer a terse response. 0.94. What is the ratio of the Expenses (in $) of South Africa in 2002 to that in 2003?
Ensure brevity in your answer.  0.9. What is the ratio of the Expenses (in $) of France in 2002 to that in 2004?
Provide a short and direct response. 0.95. What is the ratio of the Expenses (in $) of Indonesia in 2002 to that in 2004?
Provide a succinct answer. 0.43. What is the ratio of the Expenses (in $) of Lithuania in 2002 to that in 2004?
Offer a very short reply. 0.83. What is the ratio of the Expenses (in $) in South Africa in 2002 to that in 2004?
Your response must be concise. 0.8. What is the ratio of the Expenses (in $) in France in 2002 to that in 2005?
Give a very brief answer. 0.93. What is the ratio of the Expenses (in $) in Indonesia in 2002 to that in 2005?
Keep it short and to the point. 0.44. What is the ratio of the Expenses (in $) in Lithuania in 2002 to that in 2005?
Ensure brevity in your answer.  0.68. What is the ratio of the Expenses (in $) in South Africa in 2002 to that in 2005?
Offer a terse response. 0.72. What is the ratio of the Expenses (in $) of France in 2002 to that in 2006?
Provide a short and direct response. 0.91. What is the ratio of the Expenses (in $) of Indonesia in 2002 to that in 2006?
Give a very brief answer. 0.29. What is the ratio of the Expenses (in $) in Lithuania in 2002 to that in 2006?
Your answer should be compact. 0.59. What is the ratio of the Expenses (in $) of South Africa in 2002 to that in 2006?
Your response must be concise. 0.66. What is the ratio of the Expenses (in $) in France in 2002 to that in 2007?
Your answer should be very brief. 0.89. What is the ratio of the Expenses (in $) of Indonesia in 2002 to that in 2007?
Ensure brevity in your answer.  0.24. What is the ratio of the Expenses (in $) of Lithuania in 2002 to that in 2007?
Keep it short and to the point. 0.53. What is the ratio of the Expenses (in $) in South Africa in 2002 to that in 2007?
Provide a succinct answer. 0.57. What is the ratio of the Expenses (in $) in France in 2002 to that in 2008?
Your answer should be compact. 0.88. What is the ratio of the Expenses (in $) in Indonesia in 2002 to that in 2008?
Keep it short and to the point. 0.19. What is the ratio of the Expenses (in $) in Lithuania in 2002 to that in 2008?
Keep it short and to the point. 0.44. What is the ratio of the Expenses (in $) in South Africa in 2002 to that in 2008?
Ensure brevity in your answer.  0.51. What is the ratio of the Expenses (in $) in France in 2002 to that in 2009?
Keep it short and to the point. 0.86. What is the ratio of the Expenses (in $) of Indonesia in 2002 to that in 2009?
Your answer should be very brief. 0.17. What is the ratio of the Expenses (in $) in Lithuania in 2002 to that in 2009?
Provide a succinct answer. 0.47. What is the ratio of the Expenses (in $) of South Africa in 2002 to that in 2009?
Provide a short and direct response. 0.45. What is the ratio of the Expenses (in $) in France in 2003 to that in 2004?
Your answer should be compact. 0.98. What is the ratio of the Expenses (in $) in Indonesia in 2003 to that in 2004?
Your answer should be compact. 0.97. What is the ratio of the Expenses (in $) in Lithuania in 2003 to that in 2004?
Provide a short and direct response. 0.88. What is the ratio of the Expenses (in $) in South Africa in 2003 to that in 2004?
Give a very brief answer. 0.9. What is the ratio of the Expenses (in $) of France in 2003 to that in 2005?
Provide a succinct answer. 0.95. What is the ratio of the Expenses (in $) of Indonesia in 2003 to that in 2005?
Your response must be concise. 0.99. What is the ratio of the Expenses (in $) of Lithuania in 2003 to that in 2005?
Give a very brief answer. 0.73. What is the ratio of the Expenses (in $) in South Africa in 2003 to that in 2005?
Offer a terse response. 0.8. What is the ratio of the Expenses (in $) of France in 2003 to that in 2006?
Give a very brief answer. 0.93. What is the ratio of the Expenses (in $) of Indonesia in 2003 to that in 2006?
Offer a terse response. 0.65. What is the ratio of the Expenses (in $) of Lithuania in 2003 to that in 2006?
Keep it short and to the point. 0.62. What is the ratio of the Expenses (in $) in South Africa in 2003 to that in 2006?
Keep it short and to the point. 0.73. What is the ratio of the Expenses (in $) in France in 2003 to that in 2007?
Keep it short and to the point. 0.92. What is the ratio of the Expenses (in $) of Indonesia in 2003 to that in 2007?
Your answer should be very brief. 0.53. What is the ratio of the Expenses (in $) of Lithuania in 2003 to that in 2007?
Ensure brevity in your answer.  0.57. What is the ratio of the Expenses (in $) in South Africa in 2003 to that in 2007?
Keep it short and to the point. 0.64. What is the ratio of the Expenses (in $) in France in 2003 to that in 2008?
Provide a succinct answer. 0.91. What is the ratio of the Expenses (in $) in Indonesia in 2003 to that in 2008?
Give a very brief answer. 0.42. What is the ratio of the Expenses (in $) of Lithuania in 2003 to that in 2008?
Provide a short and direct response. 0.47. What is the ratio of the Expenses (in $) in South Africa in 2003 to that in 2008?
Give a very brief answer. 0.57. What is the ratio of the Expenses (in $) in France in 2003 to that in 2009?
Give a very brief answer. 0.88. What is the ratio of the Expenses (in $) in Indonesia in 2003 to that in 2009?
Keep it short and to the point. 0.37. What is the ratio of the Expenses (in $) of Lithuania in 2003 to that in 2009?
Provide a short and direct response. 0.5. What is the ratio of the Expenses (in $) in South Africa in 2003 to that in 2009?
Provide a succinct answer. 0.5. What is the ratio of the Expenses (in $) in Lithuania in 2004 to that in 2005?
Make the answer very short. 0.82. What is the ratio of the Expenses (in $) of South Africa in 2004 to that in 2005?
Offer a terse response. 0.89. What is the ratio of the Expenses (in $) in France in 2004 to that in 2006?
Provide a succinct answer. 0.95. What is the ratio of the Expenses (in $) in Indonesia in 2004 to that in 2006?
Make the answer very short. 0.68. What is the ratio of the Expenses (in $) of Lithuania in 2004 to that in 2006?
Offer a very short reply. 0.7. What is the ratio of the Expenses (in $) of South Africa in 2004 to that in 2006?
Make the answer very short. 0.82. What is the ratio of the Expenses (in $) in France in 2004 to that in 2007?
Your response must be concise. 0.93. What is the ratio of the Expenses (in $) in Indonesia in 2004 to that in 2007?
Give a very brief answer. 0.55. What is the ratio of the Expenses (in $) in Lithuania in 2004 to that in 2007?
Your answer should be compact. 0.64. What is the ratio of the Expenses (in $) of France in 2004 to that in 2008?
Provide a short and direct response. 0.92. What is the ratio of the Expenses (in $) of Indonesia in 2004 to that in 2008?
Keep it short and to the point. 0.44. What is the ratio of the Expenses (in $) in Lithuania in 2004 to that in 2008?
Offer a very short reply. 0.53. What is the ratio of the Expenses (in $) in South Africa in 2004 to that in 2008?
Your answer should be compact. 0.63. What is the ratio of the Expenses (in $) in France in 2004 to that in 2009?
Provide a short and direct response. 0.9. What is the ratio of the Expenses (in $) in Indonesia in 2004 to that in 2009?
Your answer should be compact. 0.39. What is the ratio of the Expenses (in $) of Lithuania in 2004 to that in 2009?
Your answer should be very brief. 0.56. What is the ratio of the Expenses (in $) of South Africa in 2004 to that in 2009?
Ensure brevity in your answer.  0.55. What is the ratio of the Expenses (in $) in France in 2005 to that in 2006?
Your answer should be compact. 0.98. What is the ratio of the Expenses (in $) in Indonesia in 2005 to that in 2006?
Your answer should be very brief. 0.66. What is the ratio of the Expenses (in $) of Lithuania in 2005 to that in 2006?
Your response must be concise. 0.86. What is the ratio of the Expenses (in $) in South Africa in 2005 to that in 2006?
Provide a short and direct response. 0.92. What is the ratio of the Expenses (in $) in France in 2005 to that in 2007?
Make the answer very short. 0.96. What is the ratio of the Expenses (in $) of Indonesia in 2005 to that in 2007?
Offer a very short reply. 0.54. What is the ratio of the Expenses (in $) in Lithuania in 2005 to that in 2007?
Provide a short and direct response. 0.78. What is the ratio of the Expenses (in $) in South Africa in 2005 to that in 2007?
Offer a very short reply. 0.8. What is the ratio of the Expenses (in $) of France in 2005 to that in 2008?
Your answer should be compact. 0.95. What is the ratio of the Expenses (in $) in Indonesia in 2005 to that in 2008?
Offer a terse response. 0.43. What is the ratio of the Expenses (in $) of Lithuania in 2005 to that in 2008?
Your response must be concise. 0.64. What is the ratio of the Expenses (in $) in South Africa in 2005 to that in 2008?
Provide a succinct answer. 0.71. What is the ratio of the Expenses (in $) in France in 2005 to that in 2009?
Ensure brevity in your answer.  0.93. What is the ratio of the Expenses (in $) of Indonesia in 2005 to that in 2009?
Your response must be concise. 0.38. What is the ratio of the Expenses (in $) in Lithuania in 2005 to that in 2009?
Give a very brief answer. 0.68. What is the ratio of the Expenses (in $) of South Africa in 2005 to that in 2009?
Your answer should be very brief. 0.62. What is the ratio of the Expenses (in $) of France in 2006 to that in 2007?
Your answer should be compact. 0.98. What is the ratio of the Expenses (in $) in Indonesia in 2006 to that in 2007?
Your response must be concise. 0.81. What is the ratio of the Expenses (in $) in Lithuania in 2006 to that in 2007?
Your response must be concise. 0.91. What is the ratio of the Expenses (in $) in South Africa in 2006 to that in 2007?
Keep it short and to the point. 0.87. What is the ratio of the Expenses (in $) in France in 2006 to that in 2008?
Keep it short and to the point. 0.97. What is the ratio of the Expenses (in $) of Indonesia in 2006 to that in 2008?
Make the answer very short. 0.65. What is the ratio of the Expenses (in $) of Lithuania in 2006 to that in 2008?
Make the answer very short. 0.75. What is the ratio of the Expenses (in $) in South Africa in 2006 to that in 2008?
Offer a terse response. 0.77. What is the ratio of the Expenses (in $) in France in 2006 to that in 2009?
Provide a succinct answer. 0.95. What is the ratio of the Expenses (in $) in Indonesia in 2006 to that in 2009?
Offer a terse response. 0.57. What is the ratio of the Expenses (in $) of Lithuania in 2006 to that in 2009?
Give a very brief answer. 0.8. What is the ratio of the Expenses (in $) of South Africa in 2006 to that in 2009?
Your answer should be compact. 0.68. What is the ratio of the Expenses (in $) of France in 2007 to that in 2008?
Give a very brief answer. 0.99. What is the ratio of the Expenses (in $) of Indonesia in 2007 to that in 2008?
Your answer should be compact. 0.8. What is the ratio of the Expenses (in $) of Lithuania in 2007 to that in 2008?
Offer a very short reply. 0.82. What is the ratio of the Expenses (in $) of South Africa in 2007 to that in 2008?
Ensure brevity in your answer.  0.89. What is the ratio of the Expenses (in $) in France in 2007 to that in 2009?
Offer a terse response. 0.97. What is the ratio of the Expenses (in $) of Indonesia in 2007 to that in 2009?
Your answer should be very brief. 0.71. What is the ratio of the Expenses (in $) of Lithuania in 2007 to that in 2009?
Provide a short and direct response. 0.88. What is the ratio of the Expenses (in $) in South Africa in 2007 to that in 2009?
Make the answer very short. 0.78. What is the ratio of the Expenses (in $) in France in 2008 to that in 2009?
Give a very brief answer. 0.98. What is the ratio of the Expenses (in $) in Indonesia in 2008 to that in 2009?
Ensure brevity in your answer.  0.88. What is the ratio of the Expenses (in $) in Lithuania in 2008 to that in 2009?
Your answer should be compact. 1.07. What is the ratio of the Expenses (in $) of South Africa in 2008 to that in 2009?
Ensure brevity in your answer.  0.87. What is the difference between the highest and the second highest Expenses (in $) of France?
Give a very brief answer. 4.48e+09. What is the difference between the highest and the second highest Expenses (in $) in Indonesia?
Keep it short and to the point. 1.48e+13. What is the difference between the highest and the second highest Expenses (in $) in Lithuania?
Make the answer very short. 3.80e+08. What is the difference between the highest and the second highest Expenses (in $) in South Africa?
Ensure brevity in your answer.  1.38e+1. What is the difference between the highest and the lowest Expenses (in $) of France?
Offer a very short reply. 2.65e+1. What is the difference between the highest and the lowest Expenses (in $) of Indonesia?
Provide a short and direct response. 1.06e+14. What is the difference between the highest and the lowest Expenses (in $) in Lithuania?
Your answer should be very brief. 3.48e+09. What is the difference between the highest and the lowest Expenses (in $) of South Africa?
Keep it short and to the point. 6.03e+1. 